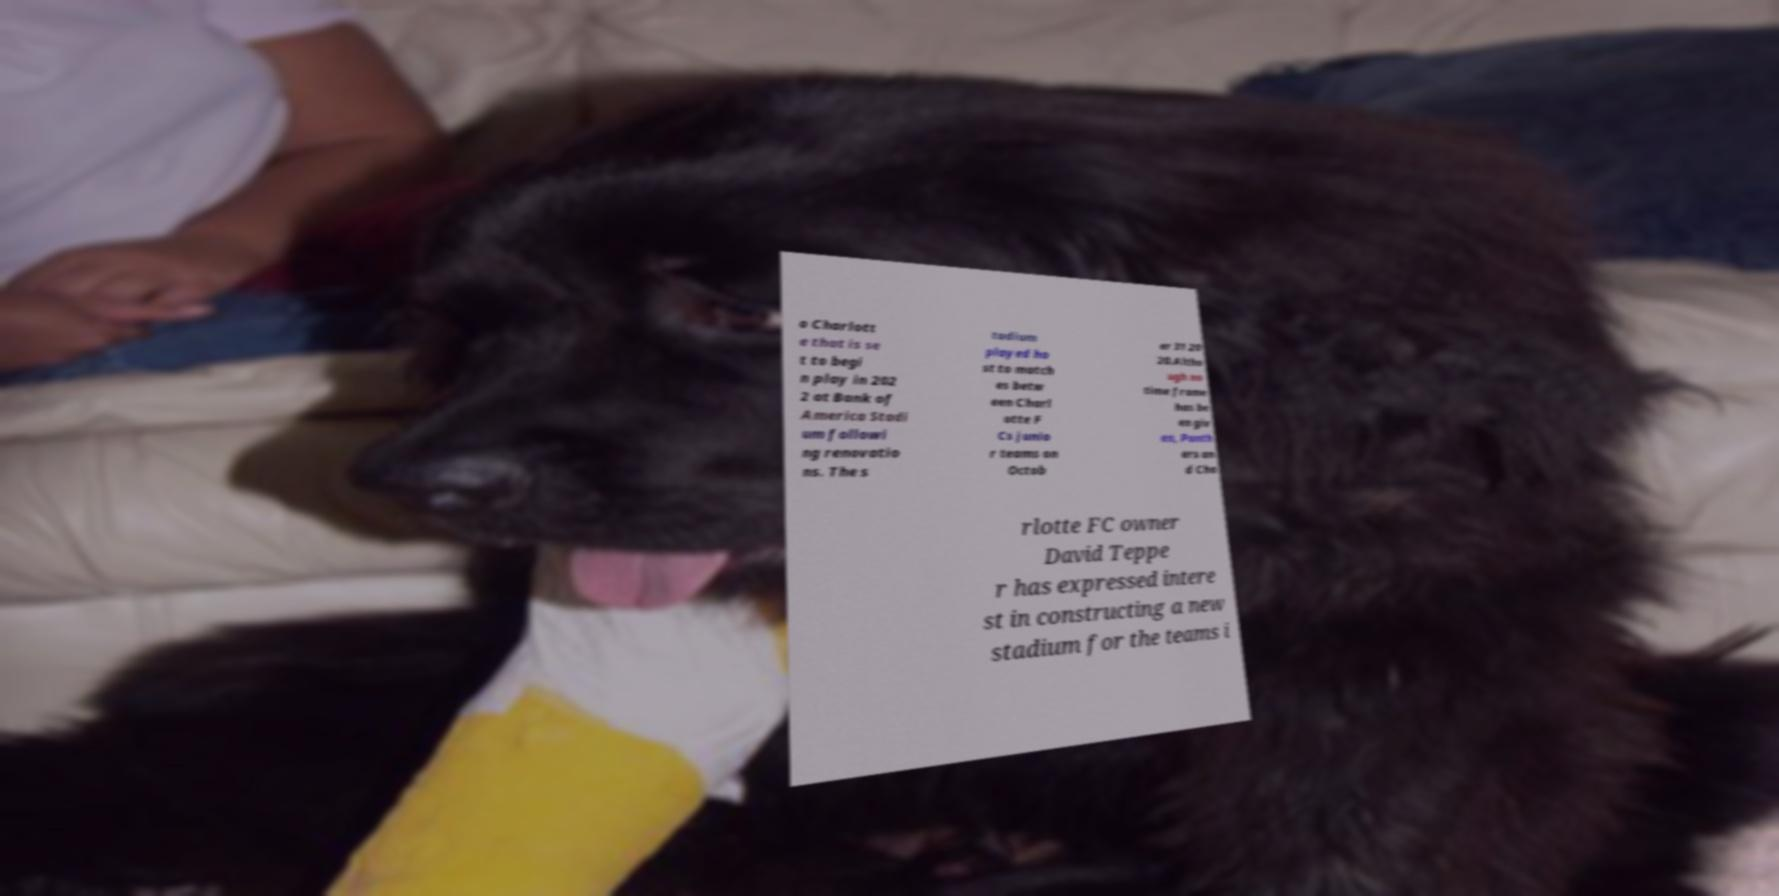Please identify and transcribe the text found in this image. o Charlott e that is se t to begi n play in 202 2 at Bank of America Stadi um followi ng renovatio ns. The s tadium played ho st to match es betw een Charl otte F Cs junio r teams on Octob er 31 20 20.Altho ugh no time frame has be en giv en, Panth ers an d Cha rlotte FC owner David Teppe r has expressed intere st in constructing a new stadium for the teams i 